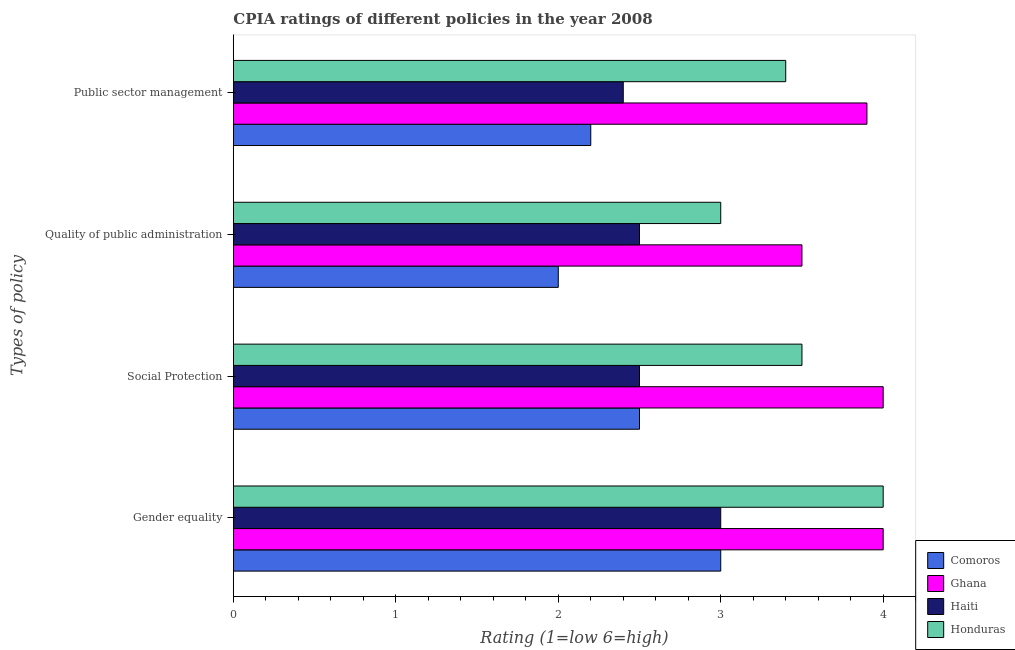How many groups of bars are there?
Ensure brevity in your answer.  4. Are the number of bars per tick equal to the number of legend labels?
Your response must be concise. Yes. What is the label of the 3rd group of bars from the top?
Your response must be concise. Social Protection. Across all countries, what is the maximum cpia rating of gender equality?
Make the answer very short. 4. In which country was the cpia rating of social protection minimum?
Offer a very short reply. Comoros. What is the total cpia rating of public sector management in the graph?
Provide a short and direct response. 11.9. What is the difference between the cpia rating of social protection in Honduras and the cpia rating of public sector management in Haiti?
Ensure brevity in your answer.  1.1. What is the average cpia rating of social protection per country?
Offer a terse response. 3.12. What is the difference between the cpia rating of public sector management and cpia rating of quality of public administration in Haiti?
Your response must be concise. -0.1. What is the ratio of the cpia rating of social protection in Comoros to that in Haiti?
Make the answer very short. 1. Is the difference between the cpia rating of public sector management in Haiti and Honduras greater than the difference between the cpia rating of social protection in Haiti and Honduras?
Your response must be concise. No. What is the difference between the highest and the lowest cpia rating of public sector management?
Your answer should be compact. 1.7. Is it the case that in every country, the sum of the cpia rating of quality of public administration and cpia rating of gender equality is greater than the sum of cpia rating of public sector management and cpia rating of social protection?
Give a very brief answer. No. What does the 2nd bar from the top in Gender equality represents?
Offer a very short reply. Haiti. What does the 4th bar from the bottom in Public sector management represents?
Keep it short and to the point. Honduras. Is it the case that in every country, the sum of the cpia rating of gender equality and cpia rating of social protection is greater than the cpia rating of quality of public administration?
Your answer should be very brief. Yes. How many bars are there?
Make the answer very short. 16. Are all the bars in the graph horizontal?
Ensure brevity in your answer.  Yes. Are the values on the major ticks of X-axis written in scientific E-notation?
Provide a succinct answer. No. Where does the legend appear in the graph?
Keep it short and to the point. Bottom right. How many legend labels are there?
Your response must be concise. 4. How are the legend labels stacked?
Provide a succinct answer. Vertical. What is the title of the graph?
Give a very brief answer. CPIA ratings of different policies in the year 2008. What is the label or title of the X-axis?
Ensure brevity in your answer.  Rating (1=low 6=high). What is the label or title of the Y-axis?
Your answer should be compact. Types of policy. What is the Rating (1=low 6=high) in Comoros in Gender equality?
Offer a terse response. 3. What is the Rating (1=low 6=high) of Ghana in Gender equality?
Keep it short and to the point. 4. What is the Rating (1=low 6=high) in Comoros in Social Protection?
Give a very brief answer. 2.5. What is the Rating (1=low 6=high) of Ghana in Social Protection?
Offer a terse response. 4. What is the Rating (1=low 6=high) of Haiti in Social Protection?
Give a very brief answer. 2.5. What is the Rating (1=low 6=high) of Comoros in Quality of public administration?
Give a very brief answer. 2. What is the Rating (1=low 6=high) in Haiti in Quality of public administration?
Keep it short and to the point. 2.5. What is the Rating (1=low 6=high) of Honduras in Quality of public administration?
Provide a short and direct response. 3. What is the Rating (1=low 6=high) of Comoros in Public sector management?
Your answer should be compact. 2.2. What is the Rating (1=low 6=high) of Ghana in Public sector management?
Make the answer very short. 3.9. What is the Rating (1=low 6=high) in Honduras in Public sector management?
Provide a short and direct response. 3.4. Across all Types of policy, what is the maximum Rating (1=low 6=high) in Comoros?
Provide a succinct answer. 3. Across all Types of policy, what is the maximum Rating (1=low 6=high) in Ghana?
Your answer should be very brief. 4. Across all Types of policy, what is the maximum Rating (1=low 6=high) of Haiti?
Offer a terse response. 3. Across all Types of policy, what is the maximum Rating (1=low 6=high) in Honduras?
Offer a very short reply. 4. Across all Types of policy, what is the minimum Rating (1=low 6=high) of Comoros?
Give a very brief answer. 2. Across all Types of policy, what is the minimum Rating (1=low 6=high) in Ghana?
Your response must be concise. 3.5. Across all Types of policy, what is the minimum Rating (1=low 6=high) in Honduras?
Ensure brevity in your answer.  3. What is the total Rating (1=low 6=high) of Ghana in the graph?
Provide a succinct answer. 15.4. What is the total Rating (1=low 6=high) in Haiti in the graph?
Offer a very short reply. 10.4. What is the total Rating (1=low 6=high) of Honduras in the graph?
Offer a very short reply. 13.9. What is the difference between the Rating (1=low 6=high) of Comoros in Gender equality and that in Social Protection?
Provide a short and direct response. 0.5. What is the difference between the Rating (1=low 6=high) in Haiti in Gender equality and that in Social Protection?
Keep it short and to the point. 0.5. What is the difference between the Rating (1=low 6=high) in Comoros in Gender equality and that in Quality of public administration?
Your answer should be compact. 1. What is the difference between the Rating (1=low 6=high) in Ghana in Gender equality and that in Quality of public administration?
Provide a succinct answer. 0.5. What is the difference between the Rating (1=low 6=high) in Honduras in Gender equality and that in Quality of public administration?
Give a very brief answer. 1. What is the difference between the Rating (1=low 6=high) in Ghana in Gender equality and that in Public sector management?
Make the answer very short. 0.1. What is the difference between the Rating (1=low 6=high) of Haiti in Gender equality and that in Public sector management?
Offer a terse response. 0.6. What is the difference between the Rating (1=low 6=high) of Honduras in Gender equality and that in Public sector management?
Make the answer very short. 0.6. What is the difference between the Rating (1=low 6=high) of Ghana in Social Protection and that in Quality of public administration?
Ensure brevity in your answer.  0.5. What is the difference between the Rating (1=low 6=high) in Honduras in Social Protection and that in Quality of public administration?
Offer a terse response. 0.5. What is the difference between the Rating (1=low 6=high) in Ghana in Social Protection and that in Public sector management?
Ensure brevity in your answer.  0.1. What is the difference between the Rating (1=low 6=high) of Haiti in Quality of public administration and that in Public sector management?
Offer a terse response. 0.1. What is the difference between the Rating (1=low 6=high) of Comoros in Gender equality and the Rating (1=low 6=high) of Haiti in Social Protection?
Provide a short and direct response. 0.5. What is the difference between the Rating (1=low 6=high) of Ghana in Gender equality and the Rating (1=low 6=high) of Honduras in Social Protection?
Keep it short and to the point. 0.5. What is the difference between the Rating (1=low 6=high) in Haiti in Gender equality and the Rating (1=low 6=high) in Honduras in Social Protection?
Provide a short and direct response. -0.5. What is the difference between the Rating (1=low 6=high) in Haiti in Gender equality and the Rating (1=low 6=high) in Honduras in Quality of public administration?
Your answer should be compact. 0. What is the difference between the Rating (1=low 6=high) of Comoros in Gender equality and the Rating (1=low 6=high) of Haiti in Public sector management?
Ensure brevity in your answer.  0.6. What is the difference between the Rating (1=low 6=high) of Comoros in Social Protection and the Rating (1=low 6=high) of Ghana in Quality of public administration?
Provide a short and direct response. -1. What is the difference between the Rating (1=low 6=high) of Comoros in Social Protection and the Rating (1=low 6=high) of Haiti in Quality of public administration?
Keep it short and to the point. 0. What is the difference between the Rating (1=low 6=high) of Haiti in Social Protection and the Rating (1=low 6=high) of Honduras in Quality of public administration?
Your answer should be very brief. -0.5. What is the difference between the Rating (1=low 6=high) of Comoros in Social Protection and the Rating (1=low 6=high) of Honduras in Public sector management?
Your answer should be compact. -0.9. What is the difference between the Rating (1=low 6=high) of Ghana in Social Protection and the Rating (1=low 6=high) of Honduras in Public sector management?
Ensure brevity in your answer.  0.6. What is the difference between the Rating (1=low 6=high) in Comoros in Quality of public administration and the Rating (1=low 6=high) in Honduras in Public sector management?
Make the answer very short. -1.4. What is the difference between the Rating (1=low 6=high) in Ghana in Quality of public administration and the Rating (1=low 6=high) in Haiti in Public sector management?
Provide a short and direct response. 1.1. What is the average Rating (1=low 6=high) in Comoros per Types of policy?
Ensure brevity in your answer.  2.42. What is the average Rating (1=low 6=high) in Ghana per Types of policy?
Ensure brevity in your answer.  3.85. What is the average Rating (1=low 6=high) in Haiti per Types of policy?
Provide a short and direct response. 2.6. What is the average Rating (1=low 6=high) of Honduras per Types of policy?
Make the answer very short. 3.48. What is the difference between the Rating (1=low 6=high) in Comoros and Rating (1=low 6=high) in Haiti in Gender equality?
Give a very brief answer. 0. What is the difference between the Rating (1=low 6=high) in Ghana and Rating (1=low 6=high) in Honduras in Gender equality?
Your answer should be very brief. 0. What is the difference between the Rating (1=low 6=high) of Haiti and Rating (1=low 6=high) of Honduras in Gender equality?
Offer a terse response. -1. What is the difference between the Rating (1=low 6=high) in Comoros and Rating (1=low 6=high) in Ghana in Social Protection?
Offer a terse response. -1.5. What is the difference between the Rating (1=low 6=high) of Comoros and Rating (1=low 6=high) of Haiti in Social Protection?
Ensure brevity in your answer.  0. What is the difference between the Rating (1=low 6=high) in Comoros and Rating (1=low 6=high) in Honduras in Social Protection?
Offer a terse response. -1. What is the difference between the Rating (1=low 6=high) of Ghana and Rating (1=low 6=high) of Haiti in Social Protection?
Provide a succinct answer. 1.5. What is the difference between the Rating (1=low 6=high) of Ghana and Rating (1=low 6=high) of Honduras in Social Protection?
Your response must be concise. 0.5. What is the difference between the Rating (1=low 6=high) in Comoros and Rating (1=low 6=high) in Ghana in Quality of public administration?
Make the answer very short. -1.5. What is the difference between the Rating (1=low 6=high) of Comoros and Rating (1=low 6=high) of Honduras in Quality of public administration?
Your answer should be very brief. -1. What is the difference between the Rating (1=low 6=high) in Ghana and Rating (1=low 6=high) in Haiti in Public sector management?
Keep it short and to the point. 1.5. What is the ratio of the Rating (1=low 6=high) of Comoros in Gender equality to that in Public sector management?
Your answer should be compact. 1.36. What is the ratio of the Rating (1=low 6=high) in Ghana in Gender equality to that in Public sector management?
Provide a short and direct response. 1.03. What is the ratio of the Rating (1=low 6=high) in Haiti in Gender equality to that in Public sector management?
Give a very brief answer. 1.25. What is the ratio of the Rating (1=low 6=high) of Honduras in Gender equality to that in Public sector management?
Your answer should be very brief. 1.18. What is the ratio of the Rating (1=low 6=high) of Comoros in Social Protection to that in Quality of public administration?
Provide a short and direct response. 1.25. What is the ratio of the Rating (1=low 6=high) in Comoros in Social Protection to that in Public sector management?
Offer a very short reply. 1.14. What is the ratio of the Rating (1=low 6=high) in Ghana in Social Protection to that in Public sector management?
Offer a very short reply. 1.03. What is the ratio of the Rating (1=low 6=high) in Haiti in Social Protection to that in Public sector management?
Make the answer very short. 1.04. What is the ratio of the Rating (1=low 6=high) in Honduras in Social Protection to that in Public sector management?
Provide a short and direct response. 1.03. What is the ratio of the Rating (1=low 6=high) of Comoros in Quality of public administration to that in Public sector management?
Offer a very short reply. 0.91. What is the ratio of the Rating (1=low 6=high) of Ghana in Quality of public administration to that in Public sector management?
Ensure brevity in your answer.  0.9. What is the ratio of the Rating (1=low 6=high) in Haiti in Quality of public administration to that in Public sector management?
Provide a short and direct response. 1.04. What is the ratio of the Rating (1=low 6=high) of Honduras in Quality of public administration to that in Public sector management?
Your answer should be compact. 0.88. What is the difference between the highest and the lowest Rating (1=low 6=high) in Comoros?
Give a very brief answer. 1. What is the difference between the highest and the lowest Rating (1=low 6=high) in Haiti?
Make the answer very short. 0.6. What is the difference between the highest and the lowest Rating (1=low 6=high) of Honduras?
Your answer should be very brief. 1. 